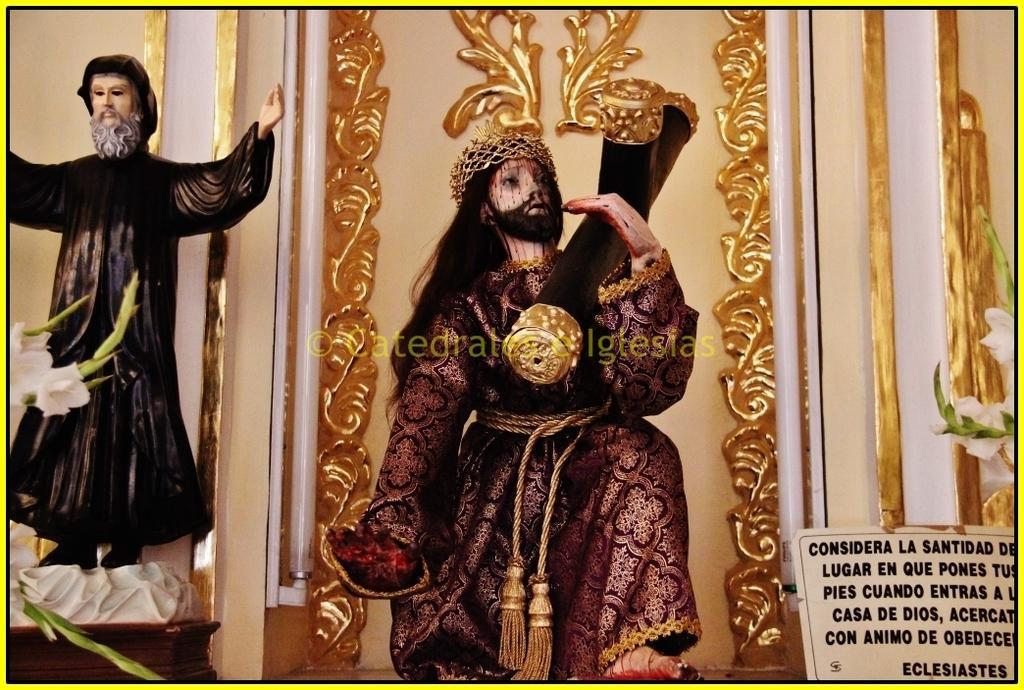In one or two sentences, can you explain what this image depicts? In this image we can see the statues, a board with some text on it, the plants with some flowers, the poles and a wall. 